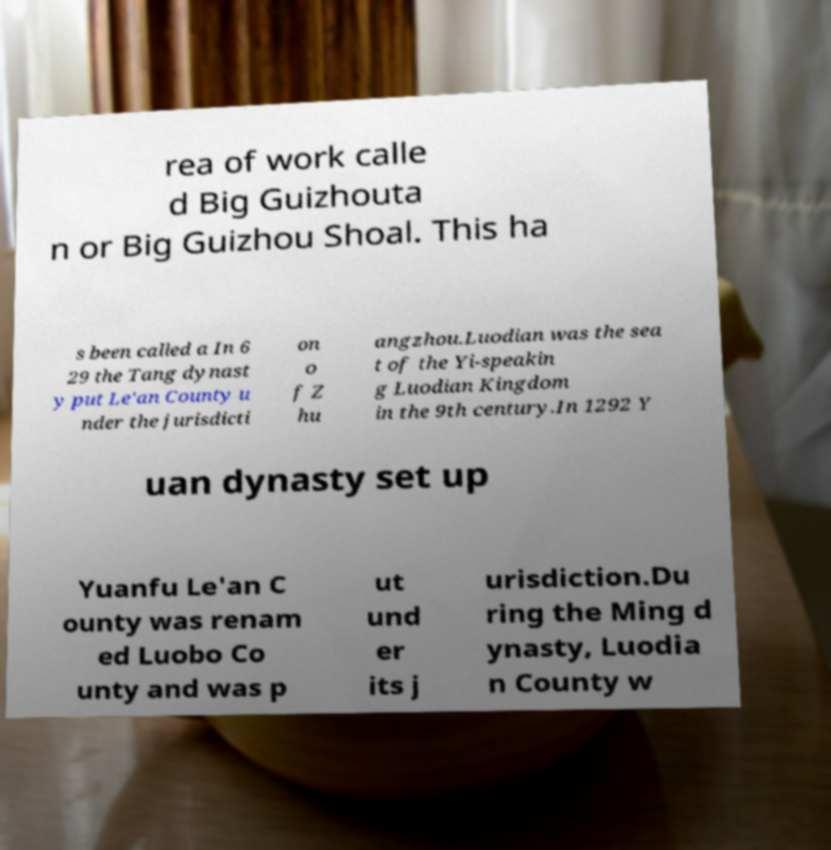Please identify and transcribe the text found in this image. rea of work calle d Big Guizhouta n or Big Guizhou Shoal. This ha s been called a In 6 29 the Tang dynast y put Le'an County u nder the jurisdicti on o f Z hu angzhou.Luodian was the sea t of the Yi-speakin g Luodian Kingdom in the 9th century.In 1292 Y uan dynasty set up Yuanfu Le'an C ounty was renam ed Luobo Co unty and was p ut und er its j urisdiction.Du ring the Ming d ynasty, Luodia n County w 